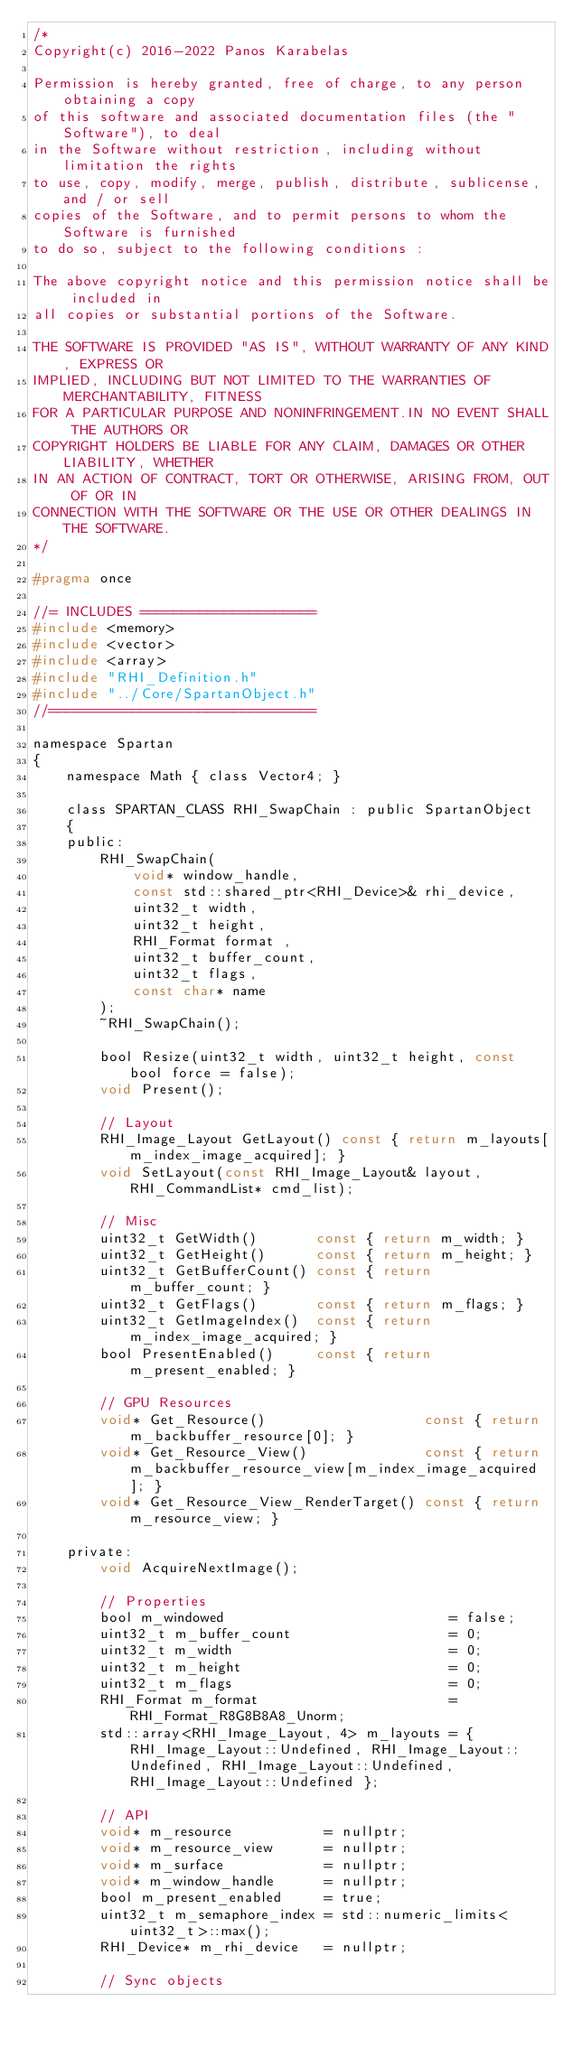<code> <loc_0><loc_0><loc_500><loc_500><_C_>/*
Copyright(c) 2016-2022 Panos Karabelas

Permission is hereby granted, free of charge, to any person obtaining a copy
of this software and associated documentation files (the "Software"), to deal
in the Software without restriction, including without limitation the rights
to use, copy, modify, merge, publish, distribute, sublicense, and / or sell
copies of the Software, and to permit persons to whom the Software is furnished
to do so, subject to the following conditions :

The above copyright notice and this permission notice shall be included in
all copies or substantial portions of the Software.

THE SOFTWARE IS PROVIDED "AS IS", WITHOUT WARRANTY OF ANY KIND, EXPRESS OR
IMPLIED, INCLUDING BUT NOT LIMITED TO THE WARRANTIES OF MERCHANTABILITY, FITNESS
FOR A PARTICULAR PURPOSE AND NONINFRINGEMENT.IN NO EVENT SHALL THE AUTHORS OR
COPYRIGHT HOLDERS BE LIABLE FOR ANY CLAIM, DAMAGES OR OTHER LIABILITY, WHETHER
IN AN ACTION OF CONTRACT, TORT OR OTHERWISE, ARISING FROM, OUT OF OR IN
CONNECTION WITH THE SOFTWARE OR THE USE OR OTHER DEALINGS IN THE SOFTWARE.
*/

#pragma once

//= INCLUDES =====================
#include <memory>
#include <vector>
#include <array>
#include "RHI_Definition.h"
#include "../Core/SpartanObject.h"
//================================

namespace Spartan
{
    namespace Math { class Vector4; }

    class SPARTAN_CLASS RHI_SwapChain : public SpartanObject
    {
    public:
        RHI_SwapChain(
            void* window_handle,
            const std::shared_ptr<RHI_Device>& rhi_device,
            uint32_t width,
            uint32_t height,
            RHI_Format format ,
            uint32_t buffer_count,
            uint32_t flags,
            const char* name
        );
        ~RHI_SwapChain();

        bool Resize(uint32_t width, uint32_t height, const bool force = false);
        void Present();

        // Layout
        RHI_Image_Layout GetLayout() const { return m_layouts[m_index_image_acquired]; }
        void SetLayout(const RHI_Image_Layout& layout, RHI_CommandList* cmd_list);

        // Misc
        uint32_t GetWidth()       const { return m_width; }
        uint32_t GetHeight()      const { return m_height; }
        uint32_t GetBufferCount() const { return m_buffer_count; }
        uint32_t GetFlags()       const { return m_flags; }
        uint32_t GetImageIndex()  const { return m_index_image_acquired; }
        bool PresentEnabled()     const { return m_present_enabled; }

        // GPU Resources
        void* Get_Resource()                   const { return m_backbuffer_resource[0]; }
        void* Get_Resource_View()              const { return m_backbuffer_resource_view[m_index_image_acquired]; }
        void* Get_Resource_View_RenderTarget() const { return m_resource_view; }

    private:
        void AcquireNextImage();

        // Properties
        bool m_windowed                           = false;
        uint32_t m_buffer_count                   = 0;
        uint32_t m_width                          = 0;
        uint32_t m_height                         = 0;
        uint32_t m_flags                          = 0;
        RHI_Format m_format                       = RHI_Format_R8G8B8A8_Unorm;
        std::array<RHI_Image_Layout, 4> m_layouts = { RHI_Image_Layout::Undefined, RHI_Image_Layout::Undefined, RHI_Image_Layout::Undefined, RHI_Image_Layout::Undefined };

        // API
        void* m_resource           = nullptr;
        void* m_resource_view      = nullptr;
        void* m_surface            = nullptr;
        void* m_window_handle      = nullptr;
        bool m_present_enabled     = true;
        uint32_t m_semaphore_index = std::numeric_limits<uint32_t>::max();
        RHI_Device* m_rhi_device   = nullptr;

        // Sync objects</code> 